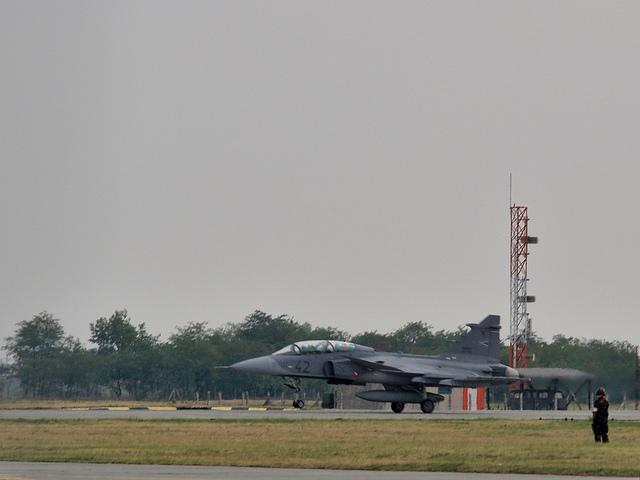What type of vehicle is this?
Be succinct. Jet. Is it raining?
Short answer required. No. Does this look like an open field?
Give a very brief answer. No. What military does the jet belong to?
Be succinct. Air force. Is it sunny?
Be succinct. No. Is it daytime?
Give a very brief answer. Yes. Is this rocket really flying?
Give a very brief answer. No. Is the plane taking off?
Short answer required. Yes. Are there clouds in the sky?
Give a very brief answer. No. Is there anyone in the image?
Keep it brief. Yes. What is the child after?
Write a very short answer. Plane. Is that a normal setting to find a horse?
Short answer required. No. What vehicle is shown?
Short answer required. Plane. What is in the picture?
Answer briefly. Jet. What is the color of the sky?
Answer briefly. Gray. Is the plane in the air?
Short answer required. No. Is there a kite?
Give a very brief answer. No. Is the aircraft off the runway?
Give a very brief answer. No. Are the people flying kites?
Answer briefly. No. Is the plane leaving the airport?
Write a very short answer. Yes. What area is this?
Write a very short answer. Airport. Where is the boy looking?
Answer briefly. At plane. What direction is the jet moving?
Answer briefly. West. What color is the plane?
Quick response, please. Gray. What is on top of the tall metal poles?
Quick response, please. Antenna. In which direction is the plane flying?
Concise answer only. Left. Is this the air force plane?
Be succinct. Yes. 